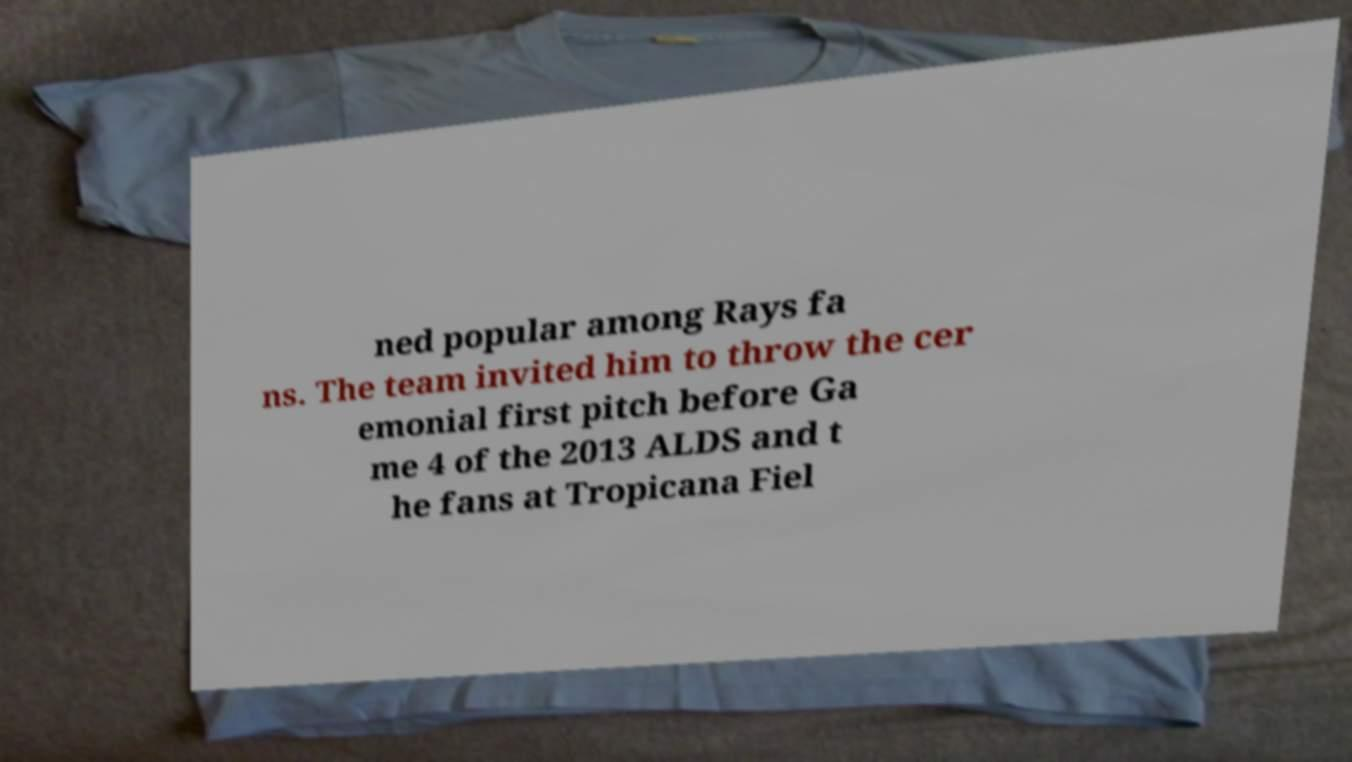What messages or text are displayed in this image? I need them in a readable, typed format. ned popular among Rays fa ns. The team invited him to throw the cer emonial first pitch before Ga me 4 of the 2013 ALDS and t he fans at Tropicana Fiel 